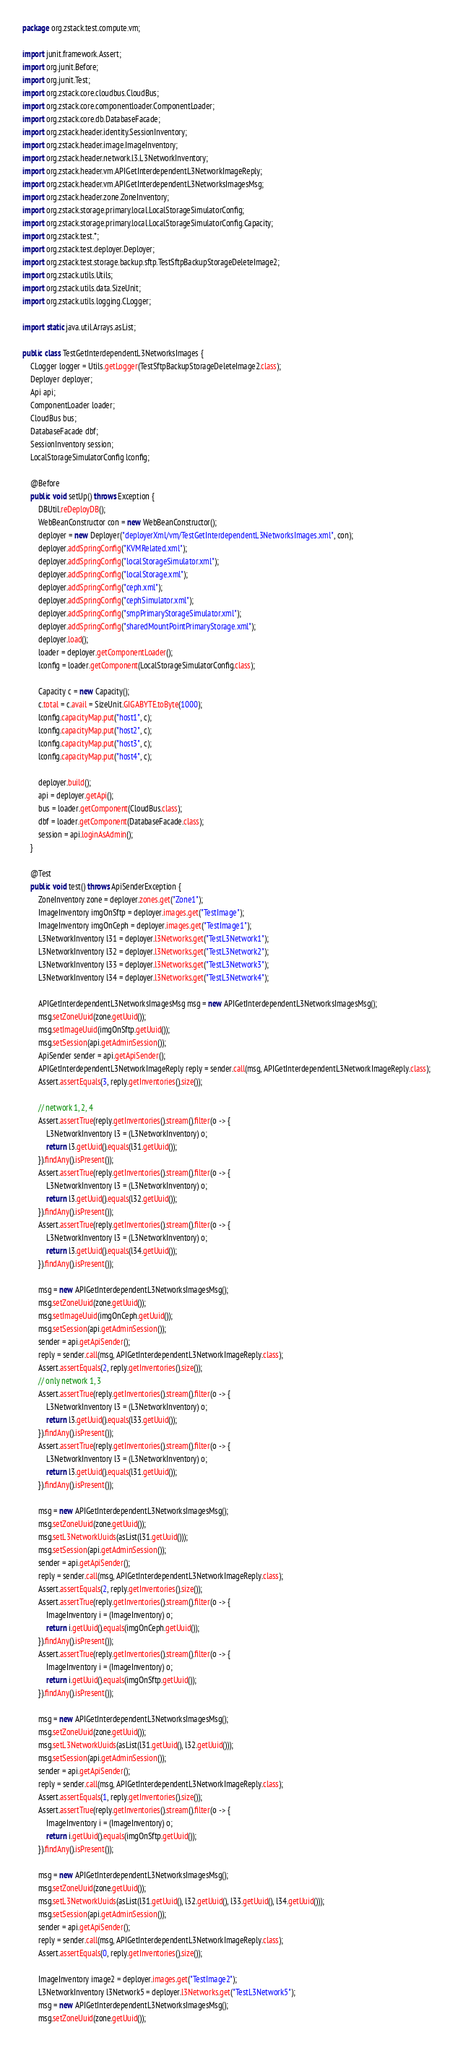<code> <loc_0><loc_0><loc_500><loc_500><_Java_>package org.zstack.test.compute.vm;

import junit.framework.Assert;
import org.junit.Before;
import org.junit.Test;
import org.zstack.core.cloudbus.CloudBus;
import org.zstack.core.componentloader.ComponentLoader;
import org.zstack.core.db.DatabaseFacade;
import org.zstack.header.identity.SessionInventory;
import org.zstack.header.image.ImageInventory;
import org.zstack.header.network.l3.L3NetworkInventory;
import org.zstack.header.vm.APIGetInterdependentL3NetworkImageReply;
import org.zstack.header.vm.APIGetInterdependentL3NetworksImagesMsg;
import org.zstack.header.zone.ZoneInventory;
import org.zstack.storage.primary.local.LocalStorageSimulatorConfig;
import org.zstack.storage.primary.local.LocalStorageSimulatorConfig.Capacity;
import org.zstack.test.*;
import org.zstack.test.deployer.Deployer;
import org.zstack.test.storage.backup.sftp.TestSftpBackupStorageDeleteImage2;
import org.zstack.utils.Utils;
import org.zstack.utils.data.SizeUnit;
import org.zstack.utils.logging.CLogger;

import static java.util.Arrays.asList;

public class TestGetInterdependentL3NetworksImages {
    CLogger logger = Utils.getLogger(TestSftpBackupStorageDeleteImage2.class);
    Deployer deployer;
    Api api;
    ComponentLoader loader;
    CloudBus bus;
    DatabaseFacade dbf;
    SessionInventory session;
    LocalStorageSimulatorConfig lconfig;

    @Before
    public void setUp() throws Exception {
        DBUtil.reDeployDB();
        WebBeanConstructor con = new WebBeanConstructor();
        deployer = new Deployer("deployerXml/vm/TestGetInterdependentL3NetworksImages.xml", con);
        deployer.addSpringConfig("KVMRelated.xml");
        deployer.addSpringConfig("localStorageSimulator.xml");
        deployer.addSpringConfig("localStorage.xml");
        deployer.addSpringConfig("ceph.xml");
        deployer.addSpringConfig("cephSimulator.xml");
        deployer.addSpringConfig("smpPrimaryStorageSimulator.xml");
        deployer.addSpringConfig("sharedMountPointPrimaryStorage.xml");
        deployer.load();
        loader = deployer.getComponentLoader();
        lconfig = loader.getComponent(LocalStorageSimulatorConfig.class);

        Capacity c = new Capacity();
        c.total = c.avail = SizeUnit.GIGABYTE.toByte(1000);
        lconfig.capacityMap.put("host1", c);
        lconfig.capacityMap.put("host2", c);
        lconfig.capacityMap.put("host3", c);
        lconfig.capacityMap.put("host4", c);

        deployer.build();
        api = deployer.getApi();
        bus = loader.getComponent(CloudBus.class);
        dbf = loader.getComponent(DatabaseFacade.class);
        session = api.loginAsAdmin();
    }

    @Test
    public void test() throws ApiSenderException {
        ZoneInventory zone = deployer.zones.get("Zone1");
        ImageInventory imgOnSftp = deployer.images.get("TestImage");
        ImageInventory imgOnCeph = deployer.images.get("TestImage1");
        L3NetworkInventory l31 = deployer.l3Networks.get("TestL3Network1");
        L3NetworkInventory l32 = deployer.l3Networks.get("TestL3Network2");
        L3NetworkInventory l33 = deployer.l3Networks.get("TestL3Network3");
        L3NetworkInventory l34 = deployer.l3Networks.get("TestL3Network4");

        APIGetInterdependentL3NetworksImagesMsg msg = new APIGetInterdependentL3NetworksImagesMsg();
        msg.setZoneUuid(zone.getUuid());
        msg.setImageUuid(imgOnSftp.getUuid());
        msg.setSession(api.getAdminSession());
        ApiSender sender = api.getApiSender();
        APIGetInterdependentL3NetworkImageReply reply = sender.call(msg, APIGetInterdependentL3NetworkImageReply.class);
        Assert.assertEquals(3, reply.getInventories().size());

        // network 1, 2, 4
        Assert.assertTrue(reply.getInventories().stream().filter(o -> {
            L3NetworkInventory l3 = (L3NetworkInventory) o;
            return l3.getUuid().equals(l31.getUuid());
        }).findAny().isPresent());
        Assert.assertTrue(reply.getInventories().stream().filter(o -> {
            L3NetworkInventory l3 = (L3NetworkInventory) o;
            return l3.getUuid().equals(l32.getUuid());
        }).findAny().isPresent());
        Assert.assertTrue(reply.getInventories().stream().filter(o -> {
            L3NetworkInventory l3 = (L3NetworkInventory) o;
            return l3.getUuid().equals(l34.getUuid());
        }).findAny().isPresent());

        msg = new APIGetInterdependentL3NetworksImagesMsg();
        msg.setZoneUuid(zone.getUuid());
        msg.setImageUuid(imgOnCeph.getUuid());
        msg.setSession(api.getAdminSession());
        sender = api.getApiSender();
        reply = sender.call(msg, APIGetInterdependentL3NetworkImageReply.class);
        Assert.assertEquals(2, reply.getInventories().size());
        // only network 1, 3
        Assert.assertTrue(reply.getInventories().stream().filter(o -> {
            L3NetworkInventory l3 = (L3NetworkInventory) o;
            return l3.getUuid().equals(l33.getUuid());
        }).findAny().isPresent());
        Assert.assertTrue(reply.getInventories().stream().filter(o -> {
            L3NetworkInventory l3 = (L3NetworkInventory) o;
            return l3.getUuid().equals(l31.getUuid());
        }).findAny().isPresent());

        msg = new APIGetInterdependentL3NetworksImagesMsg();
        msg.setZoneUuid(zone.getUuid());
        msg.setL3NetworkUuids(asList(l31.getUuid()));
        msg.setSession(api.getAdminSession());
        sender = api.getApiSender();
        reply = sender.call(msg, APIGetInterdependentL3NetworkImageReply.class);
        Assert.assertEquals(2, reply.getInventories().size());
        Assert.assertTrue(reply.getInventories().stream().filter(o -> {
            ImageInventory i = (ImageInventory) o;
            return i.getUuid().equals(imgOnCeph.getUuid());
        }).findAny().isPresent());
        Assert.assertTrue(reply.getInventories().stream().filter(o -> {
            ImageInventory i = (ImageInventory) o;
            return i.getUuid().equals(imgOnSftp.getUuid());
        }).findAny().isPresent());

        msg = new APIGetInterdependentL3NetworksImagesMsg();
        msg.setZoneUuid(zone.getUuid());
        msg.setL3NetworkUuids(asList(l31.getUuid(), l32.getUuid()));
        msg.setSession(api.getAdminSession());
        sender = api.getApiSender();
        reply = sender.call(msg, APIGetInterdependentL3NetworkImageReply.class);
        Assert.assertEquals(1, reply.getInventories().size());
        Assert.assertTrue(reply.getInventories().stream().filter(o -> {
            ImageInventory i = (ImageInventory) o;
            return i.getUuid().equals(imgOnSftp.getUuid());
        }).findAny().isPresent());

        msg = new APIGetInterdependentL3NetworksImagesMsg();
        msg.setZoneUuid(zone.getUuid());
        msg.setL3NetworkUuids(asList(l31.getUuid(), l32.getUuid(), l33.getUuid(), l34.getUuid()));
        msg.setSession(api.getAdminSession());
        sender = api.getApiSender();
        reply = sender.call(msg, APIGetInterdependentL3NetworkImageReply.class);
        Assert.assertEquals(0, reply.getInventories().size());

        ImageInventory image2 = deployer.images.get("TestImage2");
        L3NetworkInventory l3Network5 = deployer.l3Networks.get("TestL3Network5");
        msg = new APIGetInterdependentL3NetworksImagesMsg();
        msg.setZoneUuid(zone.getUuid());</code> 